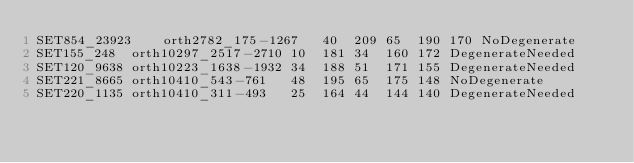<code> <loc_0><loc_0><loc_500><loc_500><_SQL_>SET854_23923	orth2782_175-1267	40	209	65	190	170	NoDegenerate
SET155_248	orth10297_2517-2710	10	181	34	160	172	DegenerateNeeded
SET120_9638	orth10223_1638-1932	34	188	51	171	155	DegenerateNeeded
SET221_8665	orth10410_543-761	48	195	65	175	148	NoDegenerate
SET220_1135	orth10410_311-493	25	164	44	144	140	DegenerateNeeded
</code> 